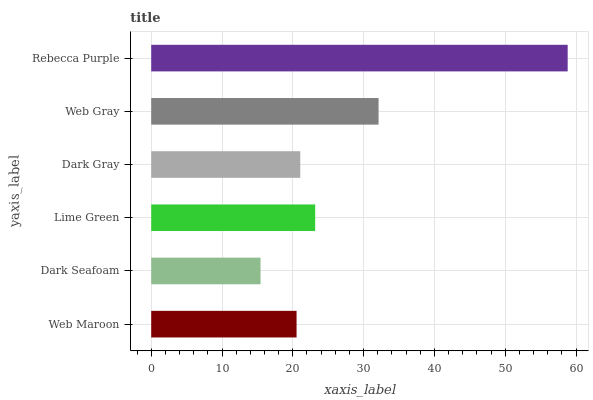Is Dark Seafoam the minimum?
Answer yes or no. Yes. Is Rebecca Purple the maximum?
Answer yes or no. Yes. Is Lime Green the minimum?
Answer yes or no. No. Is Lime Green the maximum?
Answer yes or no. No. Is Lime Green greater than Dark Seafoam?
Answer yes or no. Yes. Is Dark Seafoam less than Lime Green?
Answer yes or no. Yes. Is Dark Seafoam greater than Lime Green?
Answer yes or no. No. Is Lime Green less than Dark Seafoam?
Answer yes or no. No. Is Lime Green the high median?
Answer yes or no. Yes. Is Dark Gray the low median?
Answer yes or no. Yes. Is Dark Gray the high median?
Answer yes or no. No. Is Web Gray the low median?
Answer yes or no. No. 